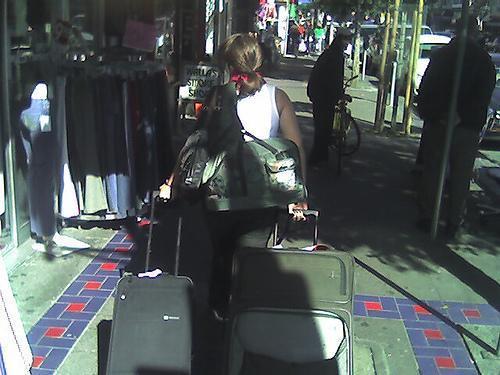How many suitcases are visible?
Give a very brief answer. 2. How many handbags can you see?
Give a very brief answer. 1. How many people are in the picture?
Give a very brief answer. 2. 